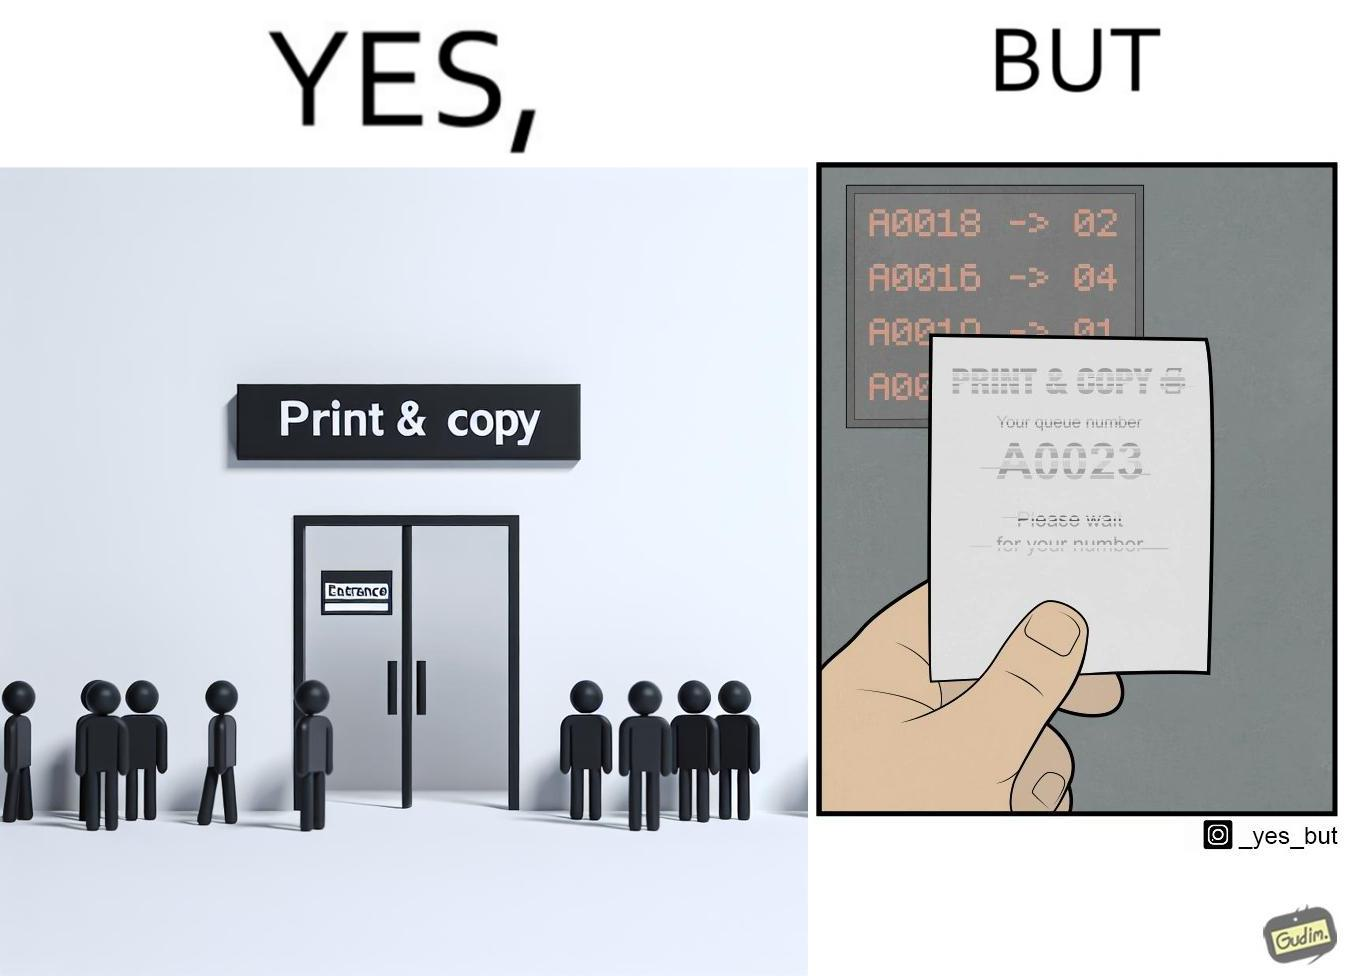What do you see in each half of this image? In the left part of the image: entrance to the "Print & Copy" Centre. In the right part of the image: printed waiting slip for the 'Print & Copy" Centre. 